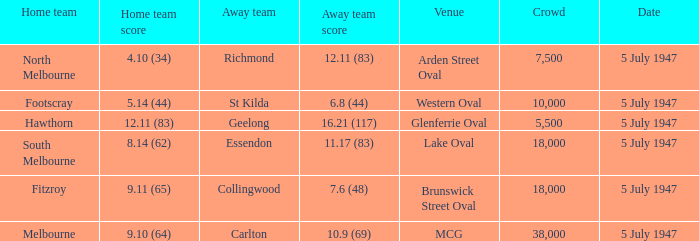Which local team faced an away team with a score of Footscray. 